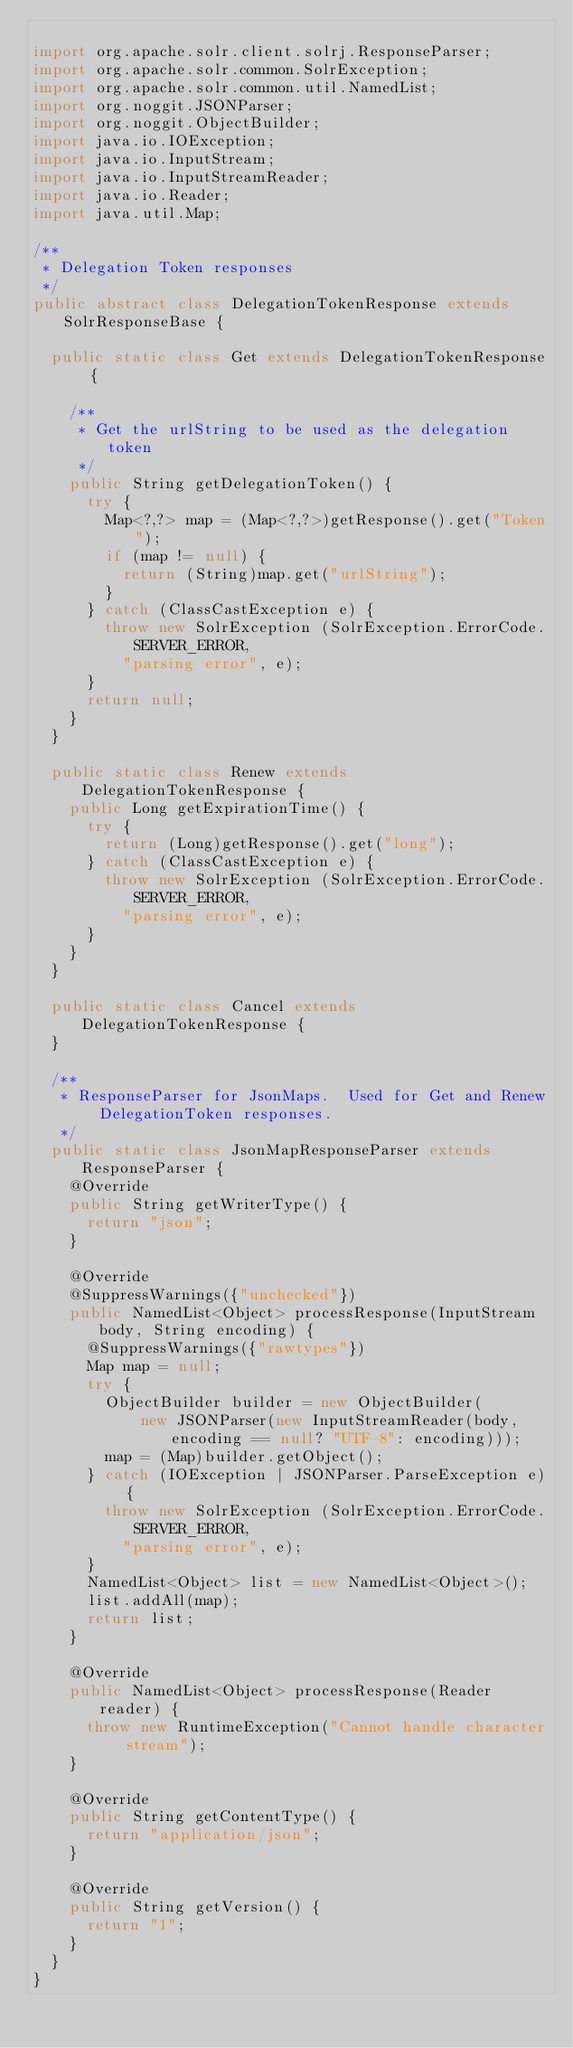<code> <loc_0><loc_0><loc_500><loc_500><_Java_>
import org.apache.solr.client.solrj.ResponseParser;
import org.apache.solr.common.SolrException;
import org.apache.solr.common.util.NamedList;
import org.noggit.JSONParser;
import org.noggit.ObjectBuilder;
import java.io.IOException;
import java.io.InputStream;
import java.io.InputStreamReader;
import java.io.Reader;
import java.util.Map;

/**
 * Delegation Token responses
 */
public abstract class DelegationTokenResponse extends SolrResponseBase {

  public static class Get extends DelegationTokenResponse {

    /**
     * Get the urlString to be used as the delegation token
     */
    public String getDelegationToken() {
      try {
        Map<?,?> map = (Map<?,?>)getResponse().get("Token");
        if (map != null) {
          return (String)map.get("urlString");
        }
      } catch (ClassCastException e) {
        throw new SolrException (SolrException.ErrorCode.SERVER_ERROR,
          "parsing error", e);
      }
      return null;
    }
  }

  public static class Renew extends DelegationTokenResponse {
    public Long getExpirationTime() {
      try {
        return (Long)getResponse().get("long");
      } catch (ClassCastException e) {
        throw new SolrException (SolrException.ErrorCode.SERVER_ERROR,
          "parsing error", e);
      }
    }
  }

  public static class Cancel extends DelegationTokenResponse {
  }

  /**
   * ResponseParser for JsonMaps.  Used for Get and Renew DelegationToken responses.
   */
  public static class JsonMapResponseParser extends ResponseParser {
    @Override
    public String getWriterType() {
      return "json";
    }

    @Override
    @SuppressWarnings({"unchecked"})
    public NamedList<Object> processResponse(InputStream body, String encoding) {
      @SuppressWarnings({"rawtypes"})
      Map map = null;
      try {
        ObjectBuilder builder = new ObjectBuilder(
            new JSONParser(new InputStreamReader(body, encoding == null? "UTF-8": encoding)));
        map = (Map)builder.getObject();
      } catch (IOException | JSONParser.ParseException e) {
        throw new SolrException (SolrException.ErrorCode.SERVER_ERROR,
          "parsing error", e);
      }
      NamedList<Object> list = new NamedList<Object>();
      list.addAll(map);
      return list;
    }

    @Override
    public NamedList<Object> processResponse(Reader reader) {
      throw new RuntimeException("Cannot handle character stream");
    }

    @Override
    public String getContentType() {
      return "application/json";
    }

    @Override
    public String getVersion() {
      return "1";
    }
  }
}
</code> 